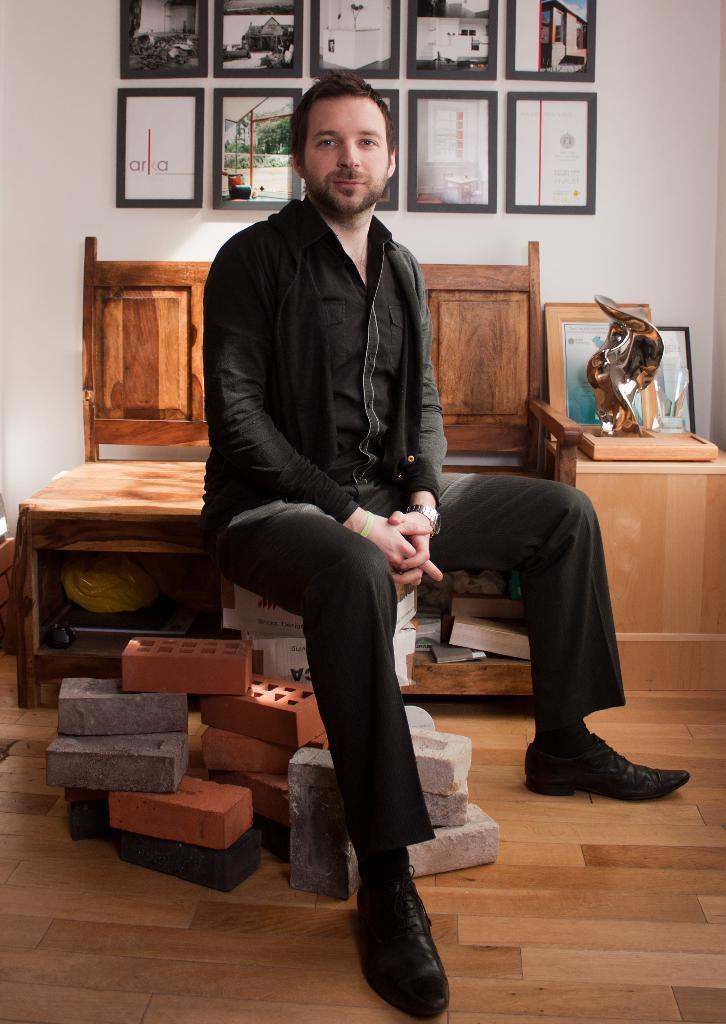Describe this image in one or two sentences. In this image we can see there is a person sitting on the stones. And at the back there is a wooden sofa and there is a table, in that there is a cover, object with design and there are photo frames attached to the wall. 